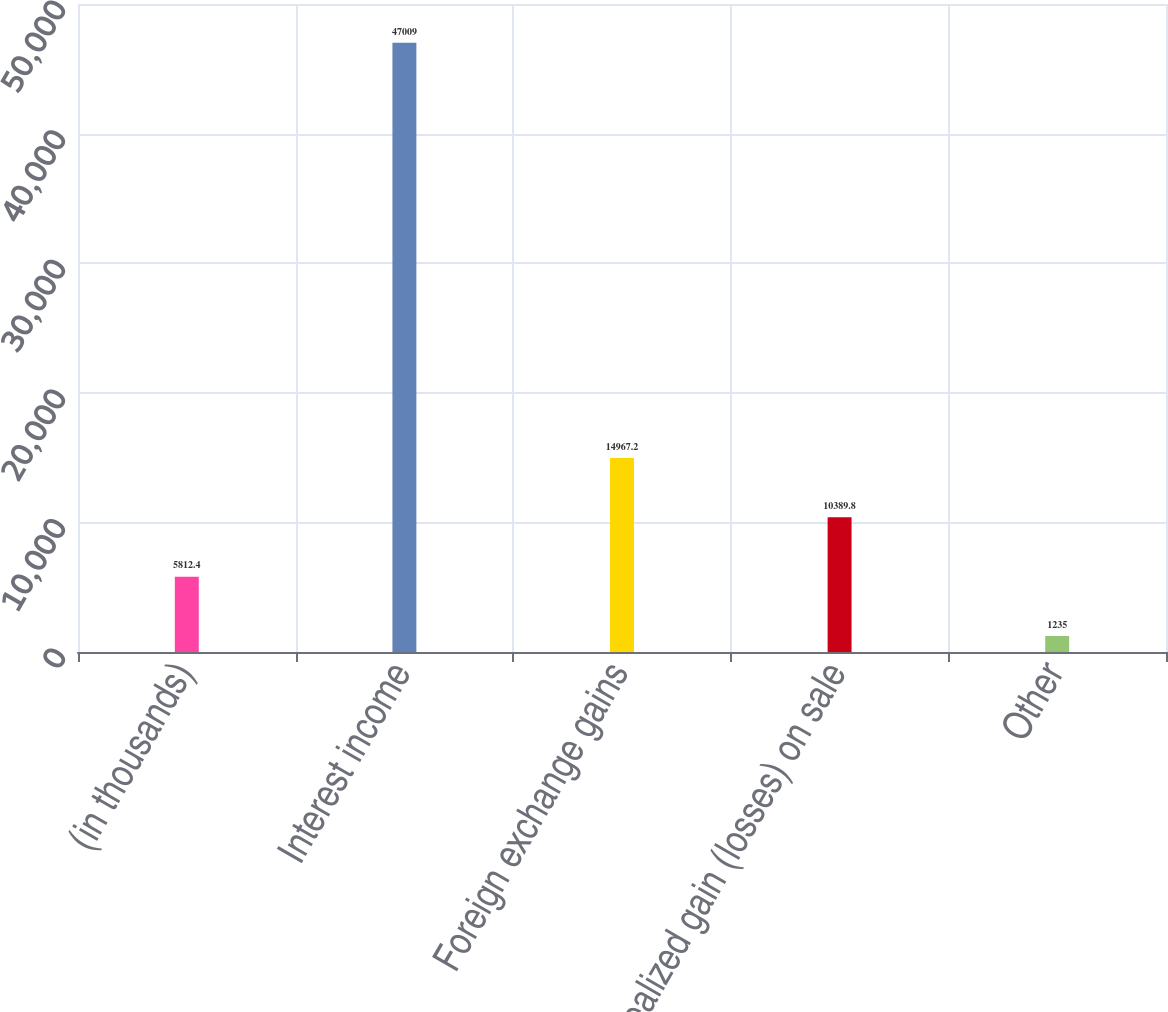<chart> <loc_0><loc_0><loc_500><loc_500><bar_chart><fcel>(in thousands)<fcel>Interest income<fcel>Foreign exchange gains<fcel>Realized gain (losses) on sale<fcel>Other<nl><fcel>5812.4<fcel>47009<fcel>14967.2<fcel>10389.8<fcel>1235<nl></chart> 